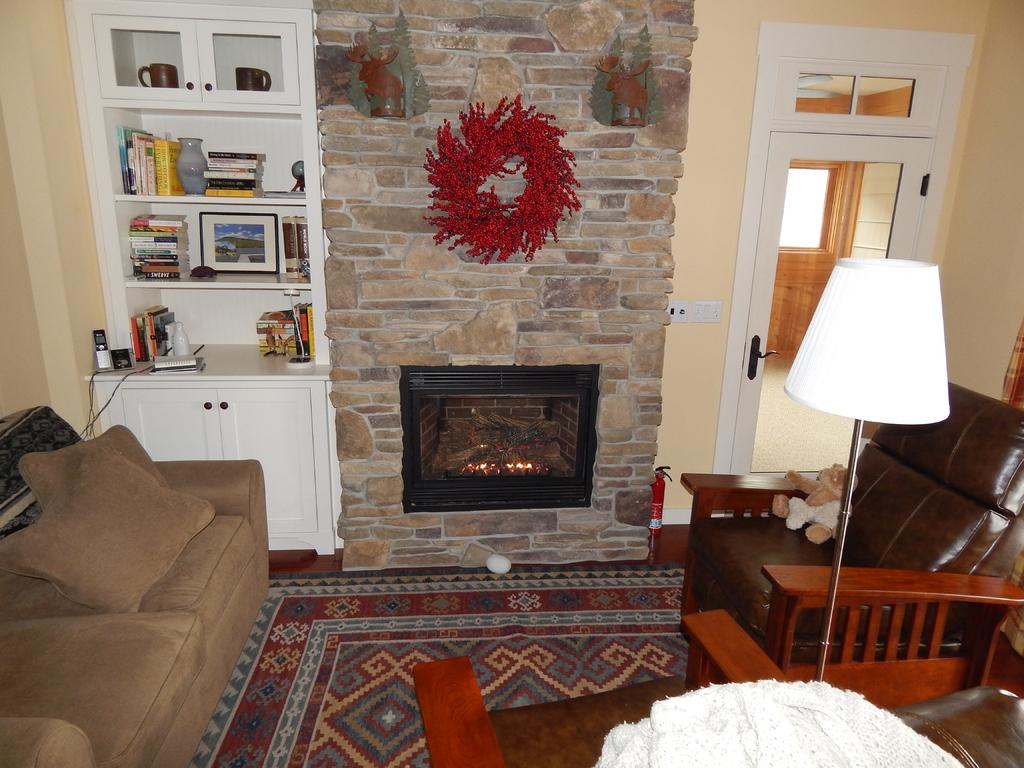What type of seating is available in the room? There is a sofa and chairs in the room. What can be found on the walls in the room? There is a wall in the room. What type of furniture is present in the room? There is furniture in the room, including a sofa, chairs, and a lamp with a stand. What can be found on the floor near the glass door? From the glass door, a floor is visible. What is the person (presumably the speaker) doing in the room? The person is sitting on a chair in the room. What type of pig can be seen playing with a can in the room? There is no pig or can present in the room; the room contains a sofa, chairs, a wall, furniture, books, a glass door, a lamp with a stand, and a person sitting on a chair. 